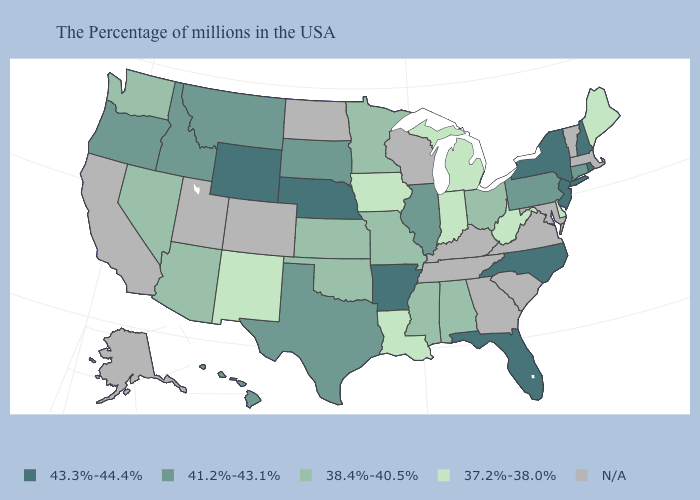What is the value of Indiana?
Keep it brief. 37.2%-38.0%. What is the value of Pennsylvania?
Write a very short answer. 41.2%-43.1%. Does Delaware have the lowest value in the USA?
Give a very brief answer. Yes. Which states hav the highest value in the West?
Keep it brief. Wyoming. What is the highest value in the MidWest ?
Answer briefly. 43.3%-44.4%. Name the states that have a value in the range 38.4%-40.5%?
Keep it brief. Ohio, Alabama, Mississippi, Missouri, Minnesota, Kansas, Oklahoma, Arizona, Nevada, Washington. Which states hav the highest value in the South?
Concise answer only. North Carolina, Florida, Arkansas. What is the value of Wisconsin?
Answer briefly. N/A. Does North Carolina have the highest value in the USA?
Short answer required. Yes. What is the value of Florida?
Give a very brief answer. 43.3%-44.4%. Name the states that have a value in the range 38.4%-40.5%?
Keep it brief. Ohio, Alabama, Mississippi, Missouri, Minnesota, Kansas, Oklahoma, Arizona, Nevada, Washington. What is the value of Ohio?
Quick response, please. 38.4%-40.5%. What is the lowest value in the USA?
Give a very brief answer. 37.2%-38.0%. Name the states that have a value in the range N/A?
Give a very brief answer. Massachusetts, Vermont, Maryland, Virginia, South Carolina, Georgia, Kentucky, Tennessee, Wisconsin, North Dakota, Colorado, Utah, California, Alaska. Which states have the lowest value in the MidWest?
Quick response, please. Michigan, Indiana, Iowa. 